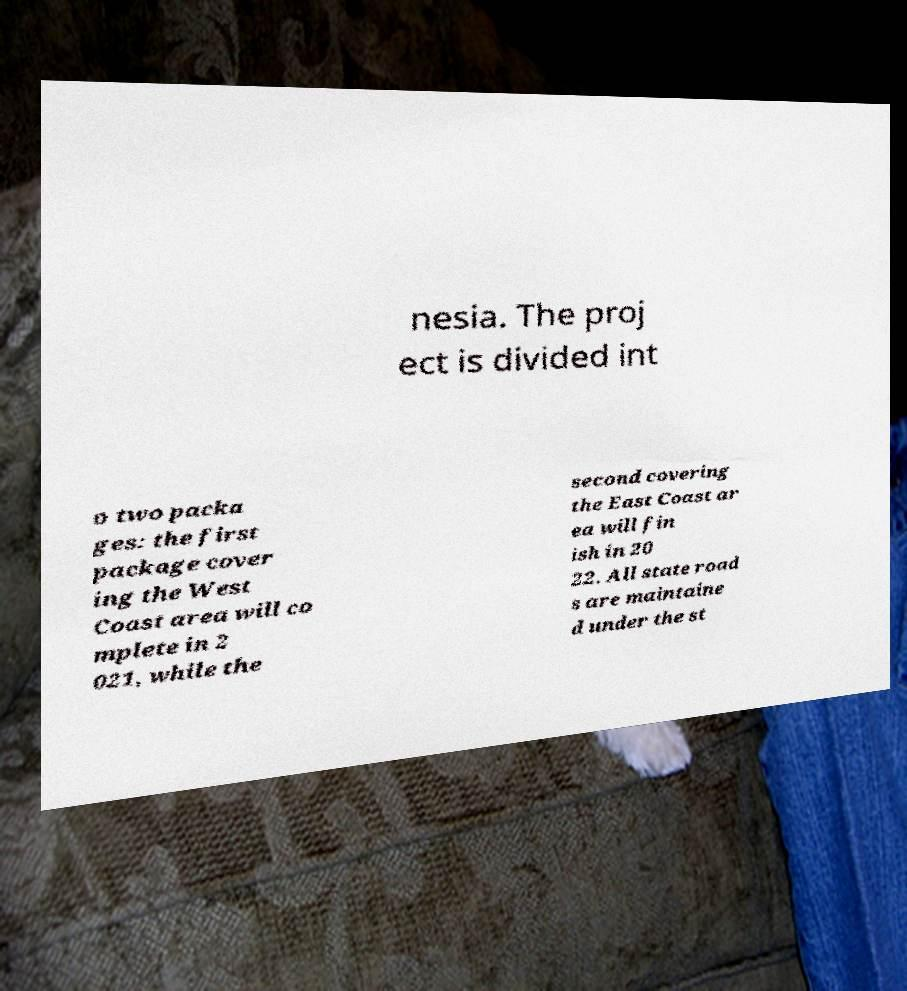Please read and relay the text visible in this image. What does it say? nesia. The proj ect is divided int o two packa ges: the first package cover ing the West Coast area will co mplete in 2 021, while the second covering the East Coast ar ea will fin ish in 20 22. All state road s are maintaine d under the st 